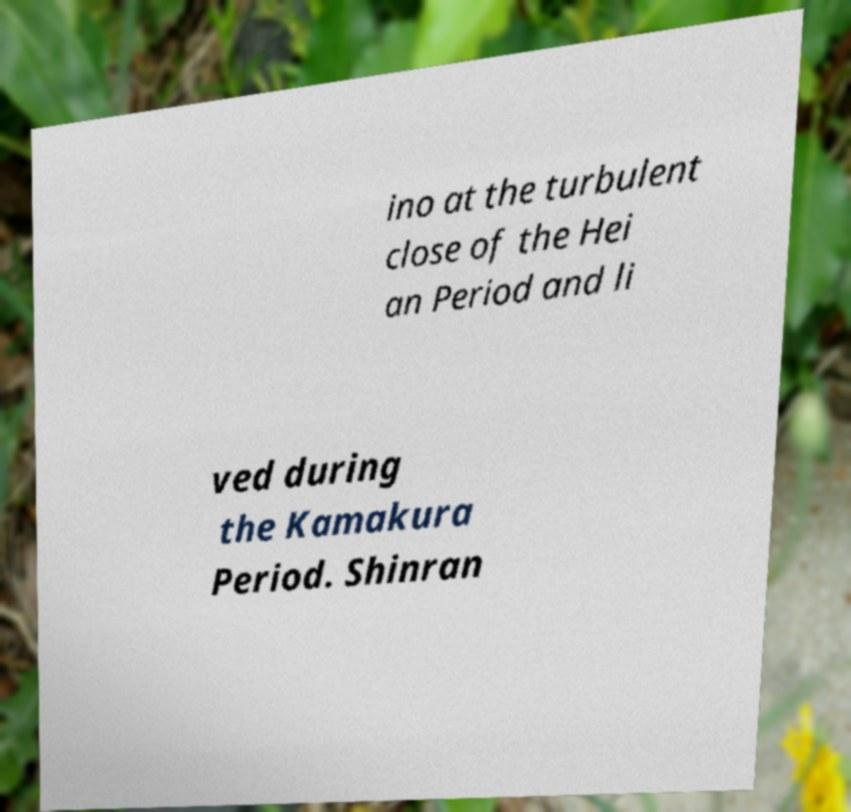What messages or text are displayed in this image? I need them in a readable, typed format. ino at the turbulent close of the Hei an Period and li ved during the Kamakura Period. Shinran 